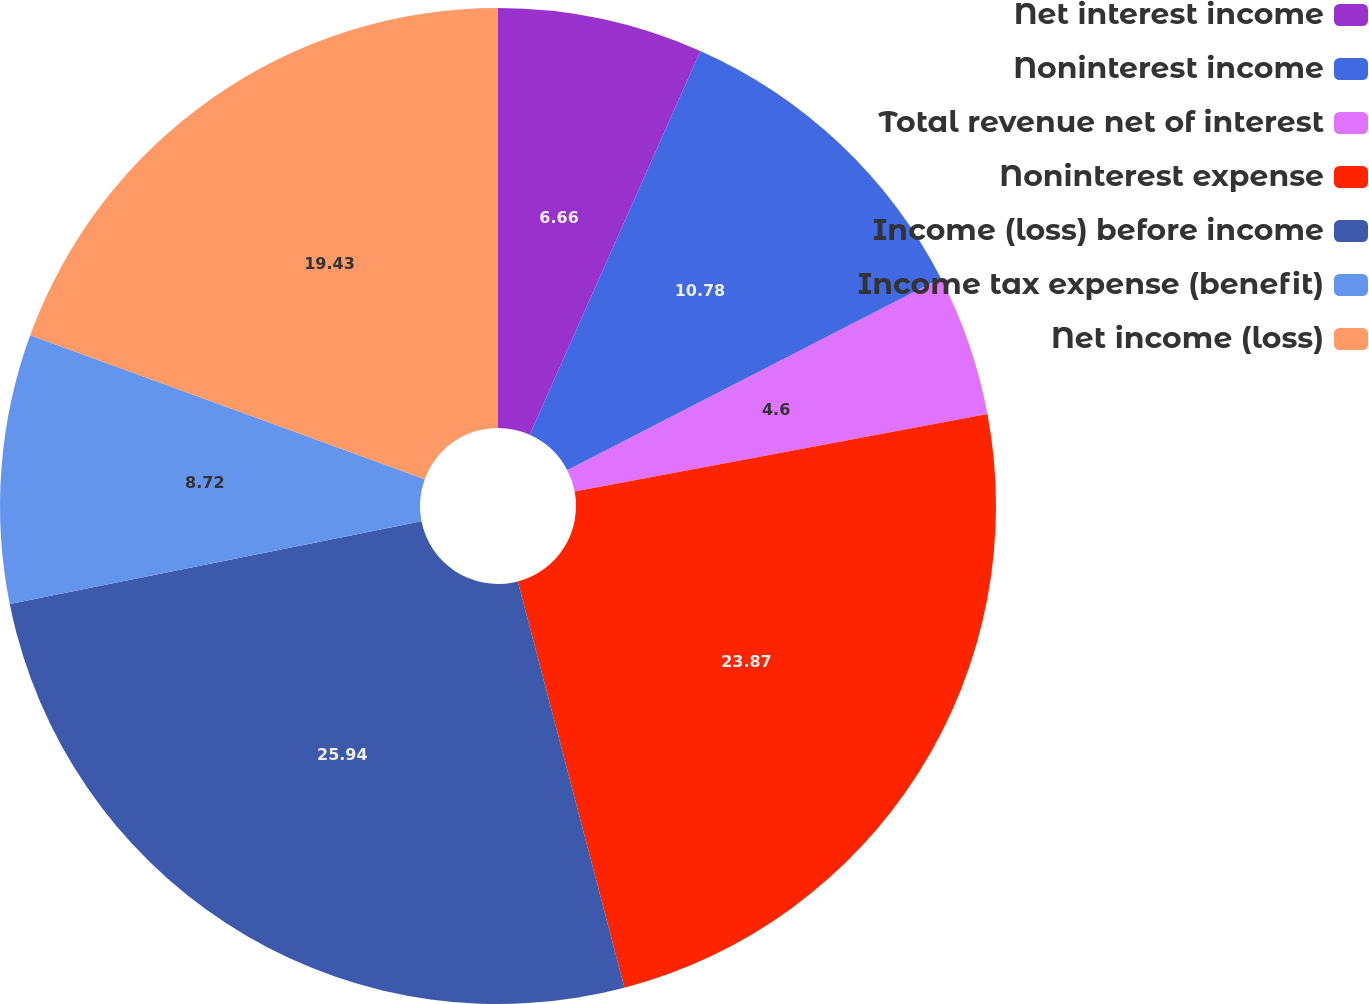Convert chart. <chart><loc_0><loc_0><loc_500><loc_500><pie_chart><fcel>Net interest income<fcel>Noninterest income<fcel>Total revenue net of interest<fcel>Noninterest expense<fcel>Income (loss) before income<fcel>Income tax expense (benefit)<fcel>Net income (loss)<nl><fcel>6.66%<fcel>10.78%<fcel>4.6%<fcel>23.87%<fcel>25.93%<fcel>8.72%<fcel>19.43%<nl></chart> 